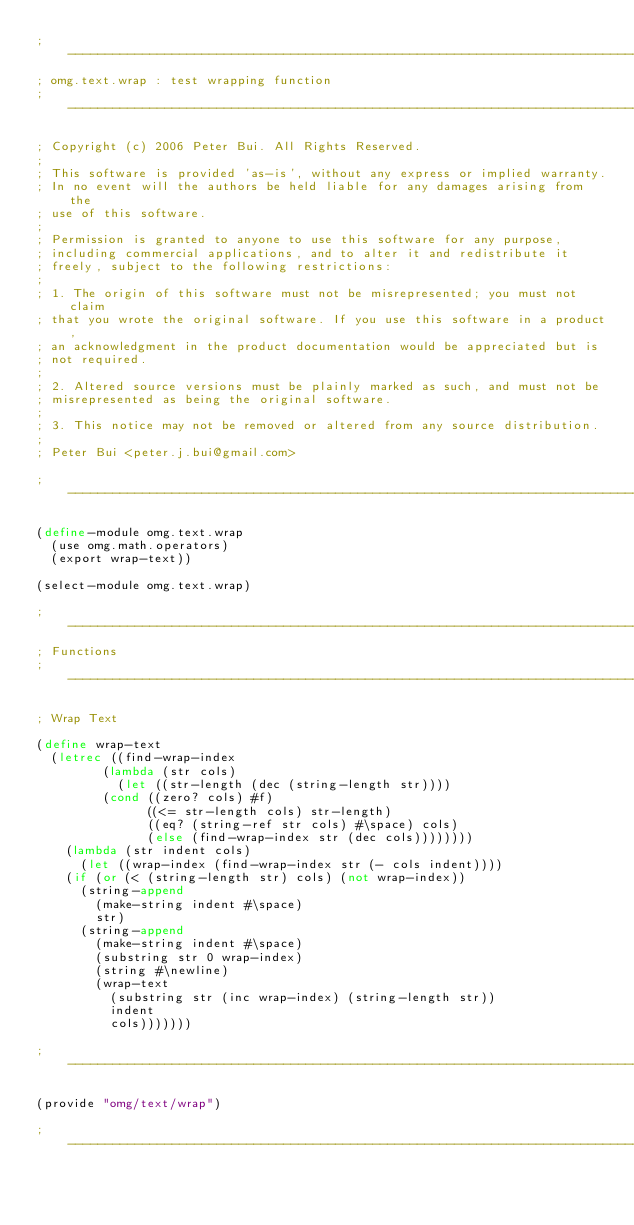<code> <loc_0><loc_0><loc_500><loc_500><_Scheme_>;------------------------------------------------------------------------------
; omg.text.wrap : test wrapping function
;------------------------------------------------------------------------------

; Copyright (c) 2006 Peter Bui. All Rights Reserved.
;
; This software is provided 'as-is', without any express or implied warranty.
; In no event will the authors be held liable for any damages arising from the
; use of this software.
;
; Permission is granted to anyone to use this software for any purpose,
; including commercial applications, and to alter it and redistribute it
; freely, subject to the following restrictions:
;
; 1. The origin of this software must not be misrepresented; you must not claim
; that you wrote the original software. If you use this software in a product,
; an acknowledgment in the product documentation would be appreciated but is
; not required.
;
; 2. Altered source versions must be plainly marked as such, and must not be
; misrepresented as being the original software.  
;
; 3. This notice may not be removed or altered from any source distribution.
;
; Peter Bui <peter.j.bui@gmail.com>

;------------------------------------------------------------------------------

(define-module omg.text.wrap
  (use omg.math.operators)
  (export wrap-text))

(select-module omg.text.wrap)

;------------------------------------------------------------------------------
; Functions
;------------------------------------------------------------------------------

; Wrap Text

(define wrap-text
  (letrec ((find-wrap-index
	     (lambda (str cols)
	       (let ((str-length (dec (string-length str))))
		 (cond ((zero? cols) #f)
		       ((<= str-length cols) str-length)
		       ((eq? (string-ref str cols) #\space) cols)
		       (else (find-wrap-index str (dec cols))))))))
    (lambda (str indent cols)
      (let ((wrap-index (find-wrap-index str (- cols indent))))
	(if (or (< (string-length str) cols) (not wrap-index))
	  (string-append 
	    (make-string indent #\space) 
	    str)
	  (string-append
	    (make-string indent #\space)
	    (substring str 0 wrap-index)
	    (string #\newline)
	    (wrap-text 
	      (substring str (inc wrap-index) (string-length str)) 
	      indent
	      cols)))))))

;------------------------------------------------------------------------------

(provide "omg/text/wrap")

;------------------------------------------------------------------------------
</code> 